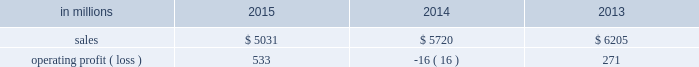Compared with $ 6.2 billion in 2013 .
Operating profits in 2015 were significantly higher than in both 2014 and 2013 .
Excluding facility closure costs , impairment costs and other special items , operating profits in 2015 were 3% ( 3 % ) lower than in 2014 and 4% ( 4 % ) higher than in 2013 .
Benefits from lower input costs ( $ 18 million ) , lower costs associated with the closure of our courtland , alabama mill ( $ 44 million ) and favorable foreign exchange ( $ 33 million ) were offset by lower average sales price realizations and mix ( $ 52 million ) , lower sales volumes ( $ 16 million ) , higher operating costs ( $ 18 million ) and higher planned maintenance downtime costs ( $ 26 million ) .
In addition , operating profits in 2014 include special items costs of $ 554 million associated with the closure of our courtland , alabama mill .
During 2013 , the company accelerated depreciation for certain courtland assets , and evaluated certain other assets for possible alternative uses by one of our other businesses .
The net book value of these assets at december 31 , 2013 was approximately $ 470 million .
In the first quarter of 2014 , we completed our evaluation and concluded that there were no alternative uses for these assets .
We recognized approximately $ 464 million of accelerated depreciation related to these assets in 2014 .
Operating profits in 2014 also include a charge of $ 32 million associated with a foreign tax amnesty program , and a gain of $ 20 million for the resolution of a legal contingency in india , while operating profits in 2013 included costs of $ 118 million associated with the announced closure of our courtland , alabama mill and a $ 123 million impairment charge associated with goodwill and a trade name intangible asset in our india papers business .
Printing papers .
North american printing papers net sales were $ 1.9 billion in 2015 , $ 2.1 billion in 2014 and $ 2.6 billion in 2013 .
Operating profits in 2015 were $ 179 million compared with a loss of $ 398 million ( a gain of $ 156 million excluding costs associated with the shutdown of our courtland , alabama mill ) in 2014 and a gain of $ 36 million ( $ 154 million excluding costs associated with the courtland mill shutdown ) in 2013 .
Sales volumes in 2015 decreased compared with 2014 primarily due to the closure of our courtland mill in 2014 .
Shipments to the domestic market increased , but export shipments declined .
Average sales price realizations decreased , primarily in the domestic market .
Input costs were lower , mainly for energy .
Planned maintenance downtime costs were $ 12 million higher in 2015 .
Operating profits in 2014 were negatively impacted by costs associated with the shutdown of our courtland , alabama mill .
Entering the first quarter of 2016 , sales volumes are expected to be up slightly compared with the fourth quarter of 2015 .
Average sales margins should be about flat reflecting lower average sales price realizations offset by a more favorable product mix .
Input costs are expected to be stable .
Planned maintenance downtime costs are expected to be about $ 14 million lower with an outage scheduled in the 2016 first quarter at our georgetown mill compared with outages at our eastover and riverdale mills in the 2015 fourth quarter .
In january 2015 , the united steelworkers , domtar corporation , packaging corporation of america , finch paper llc and p .
Glatfelter company ( the petitioners ) filed an anti-dumping petition before the united states international trade commission ( itc ) and the united states department of commerce ( doc ) alleging that paper producers in china , indonesia , australia , brazil , and portugal are selling uncoated free sheet paper in sheet form ( the products ) in violation of international trade rules .
The petitioners also filed a countervailing-duties petition with these agencies regarding imports of the products from china and indonesia .
In january 2016 , the doc announced its final countervailing duty rates on imports of the products to the united states from certain producers from china and indonesia .
Also , in january 2016 , the doc announced its final anti-dumping duty rates on imports of the products to the united states from certain producers from australia , brazil , china , indonesia and portugal .
In february 2016 , the itc concluded its anti- dumping and countervailing duties investigations and made a final determination that the u.s .
Market had been injured by imports of the products .
Accordingly , the doc 2019s previously announced countervailing duty rates and anti-dumping duty rates will be in effect for a minimum of five years .
We do not believe the impact of these rates will have a material , adverse effect on our consolidated financial statements .
Brazilian papers net sales for 2015 were $ 878 million compared with $ 1.1 billion in 2014 and $ 1.1 billion in 2013 .
Operating profits for 2015 were $ 186 million compared with $ 177 million ( $ 209 million excluding costs associated with a tax amnesty program ) in 2014 and $ 210 million in 2013 .
Sales volumes in 2015 were lower compared with 2014 reflecting weak economic conditions and the absence of 2014 one-time events .
Average sales price realizations improved for domestic uncoated freesheet paper due to the realization of price increases implemented in the second half of 2015 .
Margins were unfavorably affected by an increased proportion of sales to the lower-margin export markets .
Raw material costs increased for energy and wood .
Operating costs were higher than in 2014 , while planned maintenance downtime costs were $ 4 million lower. .
What was the profit margin from printing papers in 2013? 
Computations: (271 / 6205)
Answer: 0.04367. 